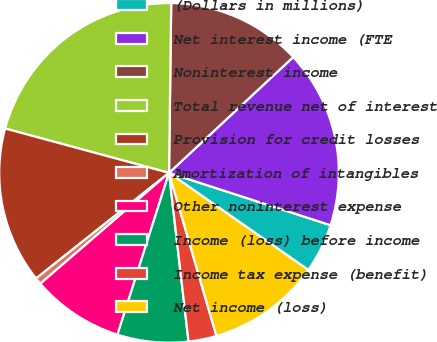<chart> <loc_0><loc_0><loc_500><loc_500><pie_chart><fcel>(Dollars in millions)<fcel>Net interest income (FTE<fcel>Noninterest income<fcel>Total revenue net of interest<fcel>Provision for credit losses<fcel>Amortization of intangibles<fcel>Other noninterest expense<fcel>Income (loss) before income<fcel>Income tax expense (benefit)<fcel>Net income (loss)<nl><fcel>4.7%<fcel>16.93%<fcel>12.85%<fcel>21.0%<fcel>14.89%<fcel>0.63%<fcel>8.78%<fcel>6.74%<fcel>2.67%<fcel>10.81%<nl></chart> 